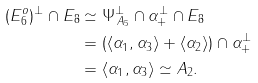<formula> <loc_0><loc_0><loc_500><loc_500>( E _ { 6 } ^ { o } ) ^ { \perp } \cap E _ { 8 } & \simeq \Psi _ { \, A _ { 5 } } ^ { \perp } \cap \alpha _ { + } ^ { \perp } \cap E _ { 8 } \\ & = ( \langle \alpha _ { 1 } , \alpha _ { 3 } \rangle + \langle \alpha _ { 2 } \rangle ) \cap \alpha _ { + } ^ { \perp } \\ & = \langle \alpha _ { 1 } , \alpha _ { 3 } \rangle \simeq A _ { 2 } .</formula> 